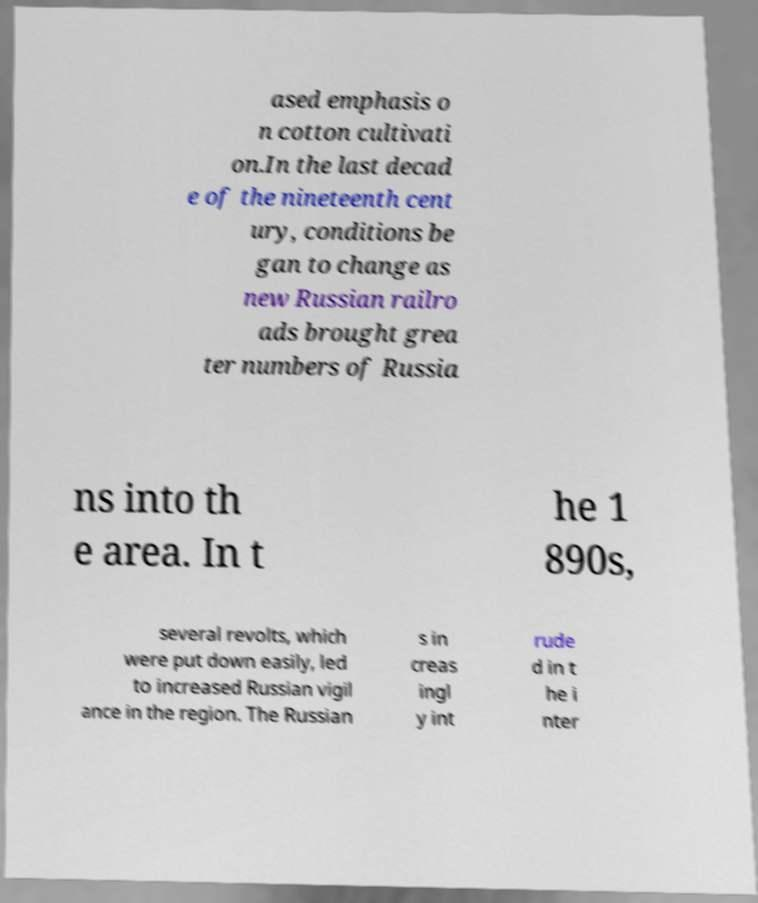Can you accurately transcribe the text from the provided image for me? ased emphasis o n cotton cultivati on.In the last decad e of the nineteenth cent ury, conditions be gan to change as new Russian railro ads brought grea ter numbers of Russia ns into th e area. In t he 1 890s, several revolts, which were put down easily, led to increased Russian vigil ance in the region. The Russian s in creas ingl y int rude d in t he i nter 